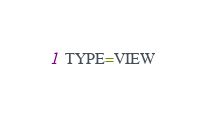Convert code to text. <code><loc_0><loc_0><loc_500><loc_500><_VisualBasic_>TYPE=VIEW</code> 